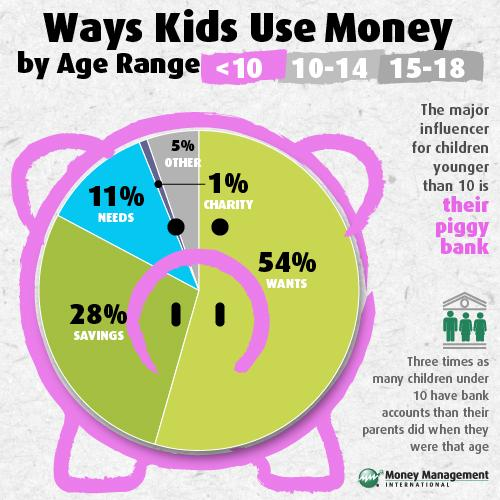Point out several critical features in this image. According to the given data, 6% of the total money used is allocated towards charity and other purposes for children. Out of the total money spent on wants and needs for children, 65% is allocated towards meeting their needs. 